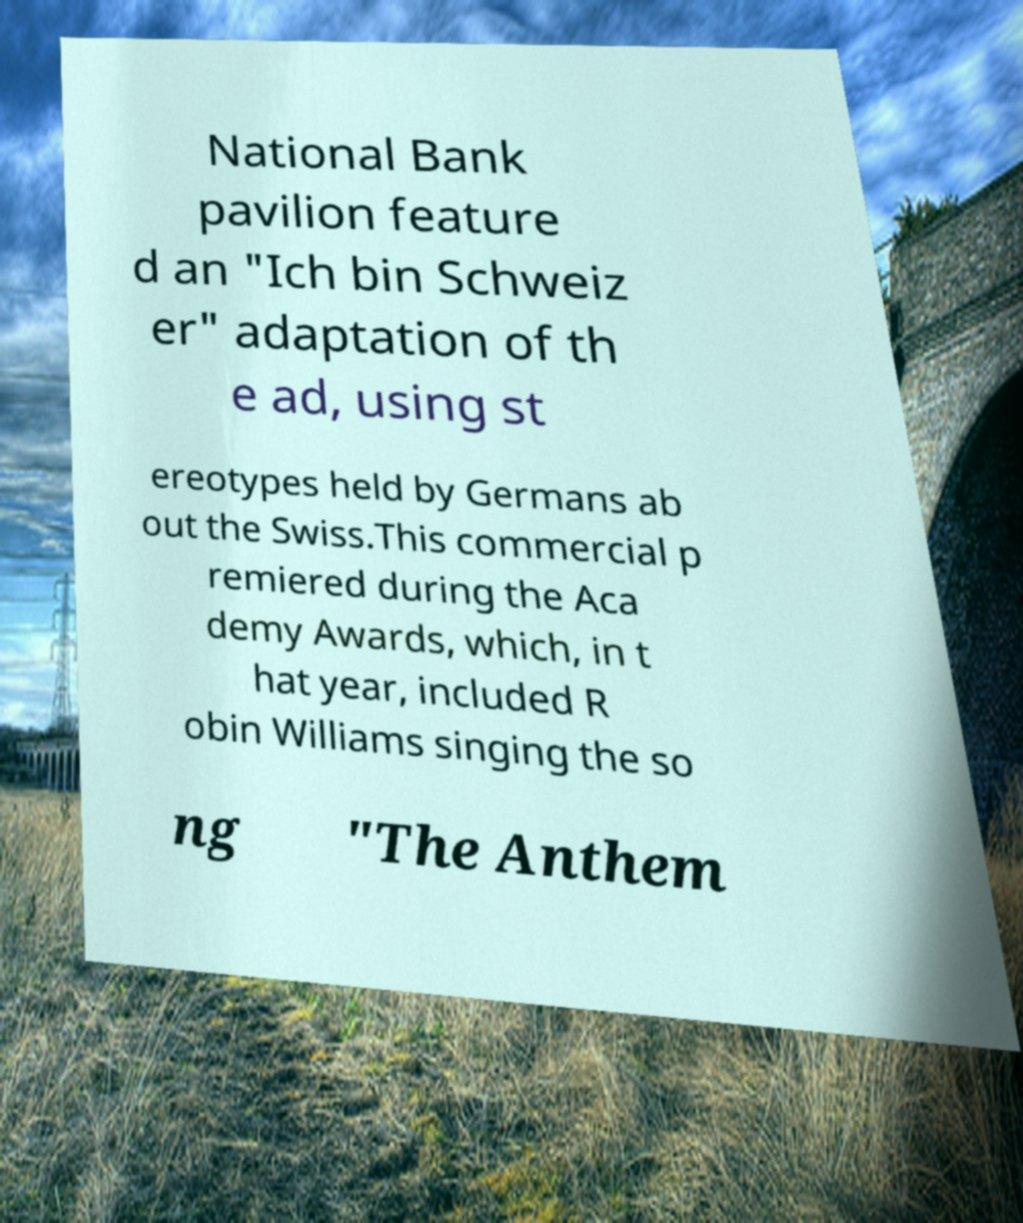There's text embedded in this image that I need extracted. Can you transcribe it verbatim? National Bank pavilion feature d an "Ich bin Schweiz er" adaptation of th e ad, using st ereotypes held by Germans ab out the Swiss.This commercial p remiered during the Aca demy Awards, which, in t hat year, included R obin Williams singing the so ng "The Anthem 